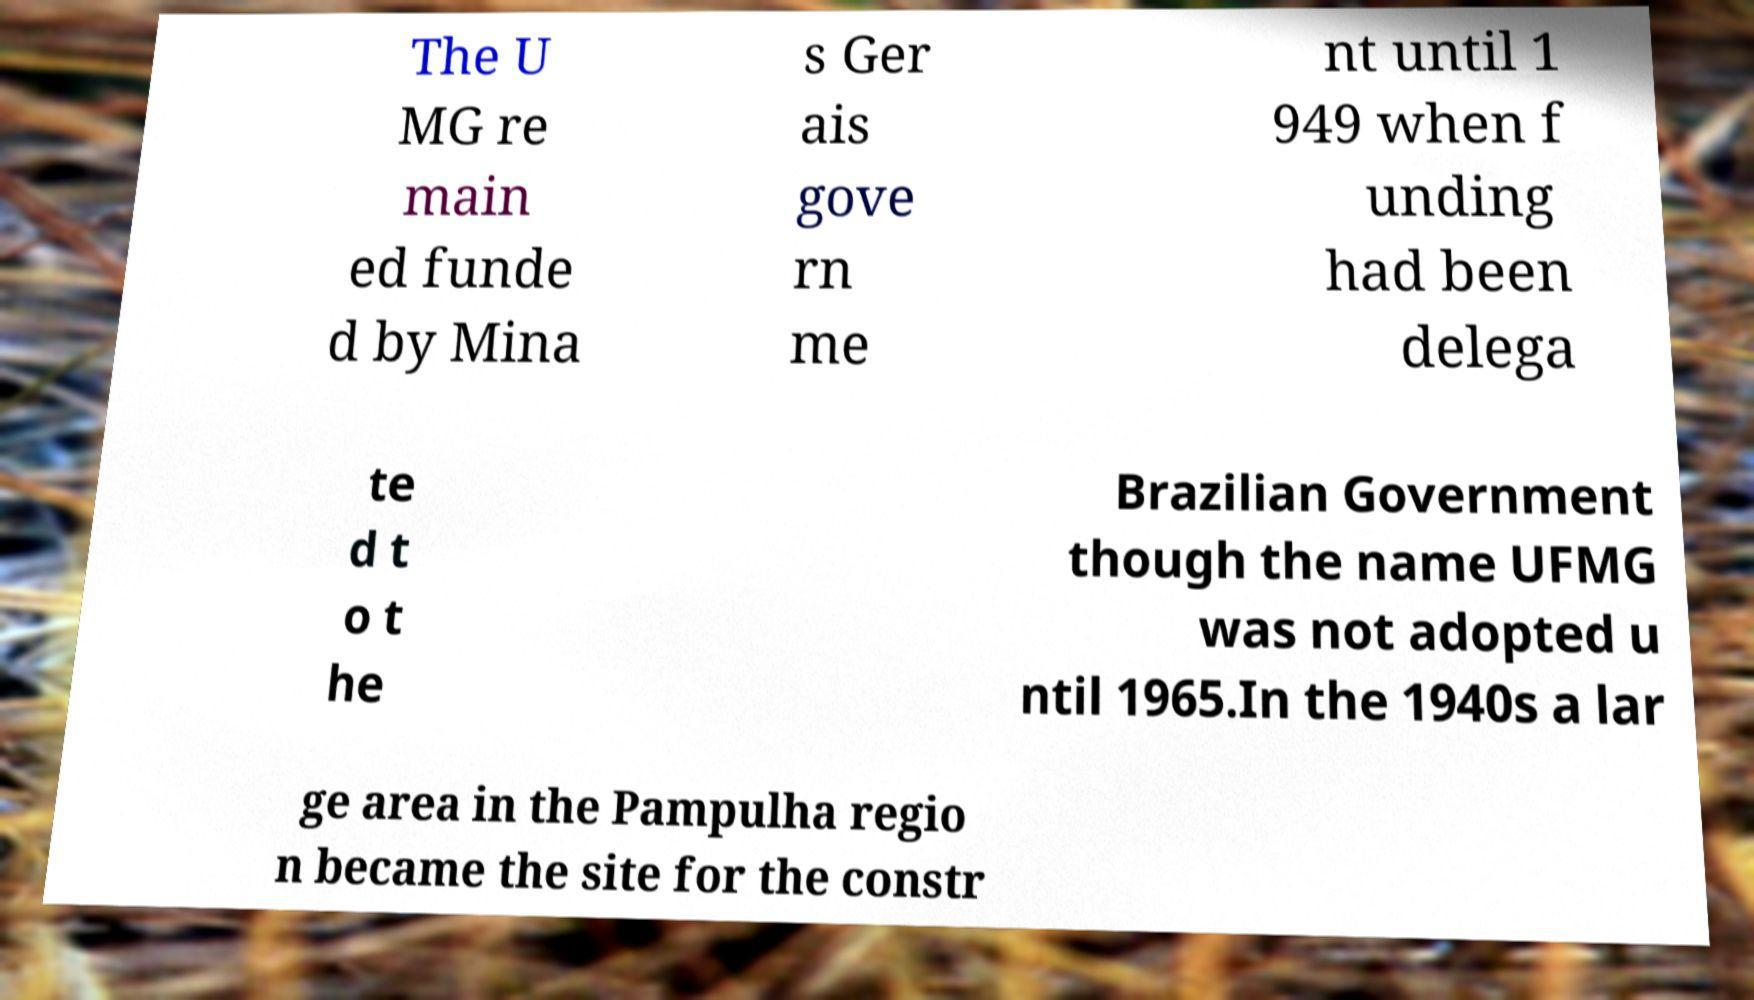Can you read and provide the text displayed in the image?This photo seems to have some interesting text. Can you extract and type it out for me? The U MG re main ed funde d by Mina s Ger ais gove rn me nt until 1 949 when f unding had been delega te d t o t he Brazilian Government though the name UFMG was not adopted u ntil 1965.In the 1940s a lar ge area in the Pampulha regio n became the site for the constr 